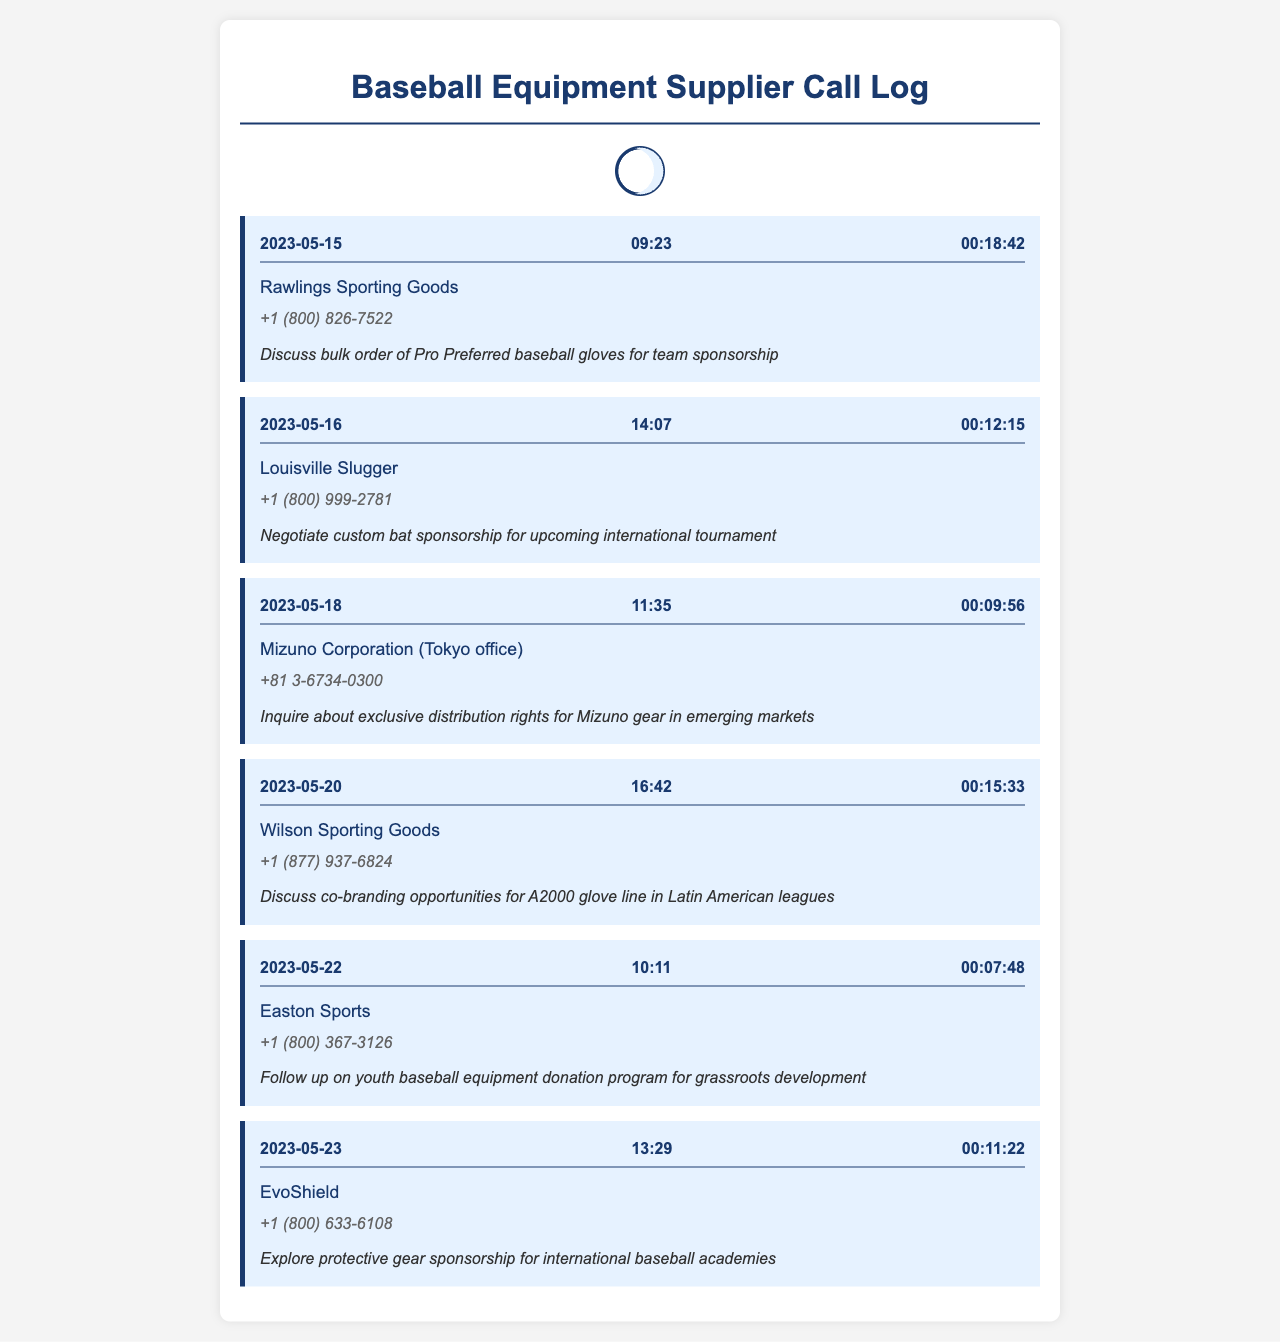What company was contacted on May 15, 2023? The call log shows that Rawlings Sporting Goods was contacted on May 15, 2023.
Answer: Rawlings Sporting Goods What was the purpose of the call to Louisville Slugger? The purpose of the call to Louisville Slugger was to negotiate a custom bat sponsorship for an upcoming international tournament.
Answer: Negotiate custom bat sponsorship for upcoming international tournament What is the duration of the call made to Easton Sports? The duration of the call made to Easton Sports is listed as 00:07:48.
Answer: 00:07:48 On which date was the call to Mizuno Corporation made? The call to Mizuno Corporation was made on May 18, 2023.
Answer: May 18, 2023 How many calls were made on May 22, 2023? There was one call made on May 22, 2023, which was to Easton Sports.
Answer: One What is the contact number for Wilson Sporting Goods? The contact number for Wilson Sporting Goods is +1 (877) 937-6824.
Answer: +1 (877) 937-6824 Which company's call purpose involved grassroots development? The call purpose involving grassroots development was related to Easton Sports, discussing a youth baseball equipment donation program.
Answer: Easton Sports How many equipment suppliers were contacted in total? A total of six equipment suppliers were contacted as listed in the call log.
Answer: Six 